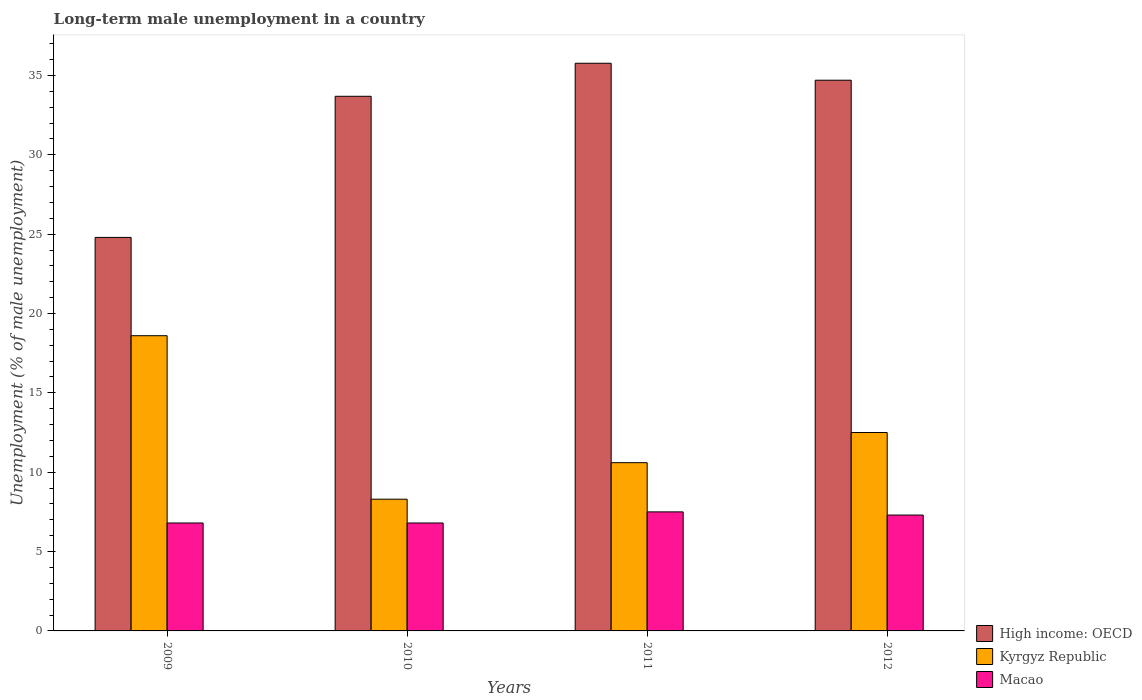Are the number of bars on each tick of the X-axis equal?
Offer a terse response. Yes. How many bars are there on the 4th tick from the left?
Give a very brief answer. 3. How many bars are there on the 3rd tick from the right?
Offer a very short reply. 3. In how many cases, is the number of bars for a given year not equal to the number of legend labels?
Offer a terse response. 0. What is the percentage of long-term unemployed male population in High income: OECD in 2012?
Your answer should be compact. 34.7. Across all years, what is the maximum percentage of long-term unemployed male population in Macao?
Your answer should be compact. 7.5. Across all years, what is the minimum percentage of long-term unemployed male population in Macao?
Provide a succinct answer. 6.8. In which year was the percentage of long-term unemployed male population in High income: OECD minimum?
Offer a terse response. 2009. What is the total percentage of long-term unemployed male population in Macao in the graph?
Make the answer very short. 28.4. What is the difference between the percentage of long-term unemployed male population in Macao in 2009 and that in 2012?
Ensure brevity in your answer.  -0.5. What is the difference between the percentage of long-term unemployed male population in High income: OECD in 2010 and the percentage of long-term unemployed male population in Kyrgyz Republic in 2012?
Provide a short and direct response. 21.19. What is the average percentage of long-term unemployed male population in Kyrgyz Republic per year?
Give a very brief answer. 12.5. In the year 2011, what is the difference between the percentage of long-term unemployed male population in Macao and percentage of long-term unemployed male population in Kyrgyz Republic?
Your response must be concise. -3.1. What is the ratio of the percentage of long-term unemployed male population in High income: OECD in 2010 to that in 2012?
Provide a succinct answer. 0.97. Is the percentage of long-term unemployed male population in Macao in 2009 less than that in 2010?
Your answer should be very brief. No. What is the difference between the highest and the second highest percentage of long-term unemployed male population in Macao?
Provide a short and direct response. 0.2. What is the difference between the highest and the lowest percentage of long-term unemployed male population in Kyrgyz Republic?
Your answer should be very brief. 10.3. In how many years, is the percentage of long-term unemployed male population in Macao greater than the average percentage of long-term unemployed male population in Macao taken over all years?
Offer a terse response. 2. What does the 2nd bar from the left in 2010 represents?
Give a very brief answer. Kyrgyz Republic. What does the 2nd bar from the right in 2009 represents?
Make the answer very short. Kyrgyz Republic. How many bars are there?
Your answer should be compact. 12. How many years are there in the graph?
Keep it short and to the point. 4. Are the values on the major ticks of Y-axis written in scientific E-notation?
Offer a very short reply. No. Does the graph contain grids?
Offer a very short reply. No. How many legend labels are there?
Offer a very short reply. 3. What is the title of the graph?
Give a very brief answer. Long-term male unemployment in a country. Does "Greece" appear as one of the legend labels in the graph?
Provide a short and direct response. No. What is the label or title of the X-axis?
Your answer should be very brief. Years. What is the label or title of the Y-axis?
Make the answer very short. Unemployment (% of male unemployment). What is the Unemployment (% of male unemployment) of High income: OECD in 2009?
Your response must be concise. 24.79. What is the Unemployment (% of male unemployment) in Kyrgyz Republic in 2009?
Ensure brevity in your answer.  18.6. What is the Unemployment (% of male unemployment) in Macao in 2009?
Offer a very short reply. 6.8. What is the Unemployment (% of male unemployment) of High income: OECD in 2010?
Your response must be concise. 33.69. What is the Unemployment (% of male unemployment) in Kyrgyz Republic in 2010?
Provide a short and direct response. 8.3. What is the Unemployment (% of male unemployment) of Macao in 2010?
Offer a very short reply. 6.8. What is the Unemployment (% of male unemployment) in High income: OECD in 2011?
Ensure brevity in your answer.  35.77. What is the Unemployment (% of male unemployment) of Kyrgyz Republic in 2011?
Ensure brevity in your answer.  10.6. What is the Unemployment (% of male unemployment) in Macao in 2011?
Your answer should be compact. 7.5. What is the Unemployment (% of male unemployment) in High income: OECD in 2012?
Keep it short and to the point. 34.7. What is the Unemployment (% of male unemployment) of Macao in 2012?
Ensure brevity in your answer.  7.3. Across all years, what is the maximum Unemployment (% of male unemployment) of High income: OECD?
Provide a succinct answer. 35.77. Across all years, what is the maximum Unemployment (% of male unemployment) of Kyrgyz Republic?
Offer a terse response. 18.6. Across all years, what is the minimum Unemployment (% of male unemployment) of High income: OECD?
Your answer should be compact. 24.79. Across all years, what is the minimum Unemployment (% of male unemployment) in Kyrgyz Republic?
Your answer should be very brief. 8.3. Across all years, what is the minimum Unemployment (% of male unemployment) of Macao?
Provide a succinct answer. 6.8. What is the total Unemployment (% of male unemployment) of High income: OECD in the graph?
Offer a very short reply. 128.94. What is the total Unemployment (% of male unemployment) of Macao in the graph?
Provide a short and direct response. 28.4. What is the difference between the Unemployment (% of male unemployment) in High income: OECD in 2009 and that in 2010?
Provide a succinct answer. -8.89. What is the difference between the Unemployment (% of male unemployment) in High income: OECD in 2009 and that in 2011?
Your response must be concise. -10.97. What is the difference between the Unemployment (% of male unemployment) in Macao in 2009 and that in 2011?
Provide a short and direct response. -0.7. What is the difference between the Unemployment (% of male unemployment) of High income: OECD in 2009 and that in 2012?
Offer a very short reply. -9.9. What is the difference between the Unemployment (% of male unemployment) in Kyrgyz Republic in 2009 and that in 2012?
Provide a short and direct response. 6.1. What is the difference between the Unemployment (% of male unemployment) in High income: OECD in 2010 and that in 2011?
Give a very brief answer. -2.08. What is the difference between the Unemployment (% of male unemployment) in Macao in 2010 and that in 2011?
Give a very brief answer. -0.7. What is the difference between the Unemployment (% of male unemployment) of High income: OECD in 2010 and that in 2012?
Offer a very short reply. -1.01. What is the difference between the Unemployment (% of male unemployment) of Kyrgyz Republic in 2010 and that in 2012?
Offer a terse response. -4.2. What is the difference between the Unemployment (% of male unemployment) of Macao in 2010 and that in 2012?
Your answer should be compact. -0.5. What is the difference between the Unemployment (% of male unemployment) of High income: OECD in 2011 and that in 2012?
Offer a very short reply. 1.07. What is the difference between the Unemployment (% of male unemployment) in Kyrgyz Republic in 2011 and that in 2012?
Provide a succinct answer. -1.9. What is the difference between the Unemployment (% of male unemployment) of High income: OECD in 2009 and the Unemployment (% of male unemployment) of Kyrgyz Republic in 2010?
Give a very brief answer. 16.49. What is the difference between the Unemployment (% of male unemployment) in High income: OECD in 2009 and the Unemployment (% of male unemployment) in Macao in 2010?
Offer a terse response. 17.99. What is the difference between the Unemployment (% of male unemployment) in Kyrgyz Republic in 2009 and the Unemployment (% of male unemployment) in Macao in 2010?
Provide a short and direct response. 11.8. What is the difference between the Unemployment (% of male unemployment) in High income: OECD in 2009 and the Unemployment (% of male unemployment) in Kyrgyz Republic in 2011?
Give a very brief answer. 14.19. What is the difference between the Unemployment (% of male unemployment) in High income: OECD in 2009 and the Unemployment (% of male unemployment) in Macao in 2011?
Make the answer very short. 17.29. What is the difference between the Unemployment (% of male unemployment) in Kyrgyz Republic in 2009 and the Unemployment (% of male unemployment) in Macao in 2011?
Provide a short and direct response. 11.1. What is the difference between the Unemployment (% of male unemployment) of High income: OECD in 2009 and the Unemployment (% of male unemployment) of Kyrgyz Republic in 2012?
Make the answer very short. 12.29. What is the difference between the Unemployment (% of male unemployment) of High income: OECD in 2009 and the Unemployment (% of male unemployment) of Macao in 2012?
Make the answer very short. 17.49. What is the difference between the Unemployment (% of male unemployment) of Kyrgyz Republic in 2009 and the Unemployment (% of male unemployment) of Macao in 2012?
Offer a very short reply. 11.3. What is the difference between the Unemployment (% of male unemployment) in High income: OECD in 2010 and the Unemployment (% of male unemployment) in Kyrgyz Republic in 2011?
Your answer should be very brief. 23.09. What is the difference between the Unemployment (% of male unemployment) in High income: OECD in 2010 and the Unemployment (% of male unemployment) in Macao in 2011?
Your answer should be very brief. 26.19. What is the difference between the Unemployment (% of male unemployment) of Kyrgyz Republic in 2010 and the Unemployment (% of male unemployment) of Macao in 2011?
Provide a short and direct response. 0.8. What is the difference between the Unemployment (% of male unemployment) of High income: OECD in 2010 and the Unemployment (% of male unemployment) of Kyrgyz Republic in 2012?
Provide a short and direct response. 21.19. What is the difference between the Unemployment (% of male unemployment) in High income: OECD in 2010 and the Unemployment (% of male unemployment) in Macao in 2012?
Keep it short and to the point. 26.39. What is the difference between the Unemployment (% of male unemployment) in High income: OECD in 2011 and the Unemployment (% of male unemployment) in Kyrgyz Republic in 2012?
Keep it short and to the point. 23.27. What is the difference between the Unemployment (% of male unemployment) in High income: OECD in 2011 and the Unemployment (% of male unemployment) in Macao in 2012?
Make the answer very short. 28.47. What is the average Unemployment (% of male unemployment) in High income: OECD per year?
Make the answer very short. 32.24. What is the average Unemployment (% of male unemployment) in Kyrgyz Republic per year?
Provide a succinct answer. 12.5. In the year 2009, what is the difference between the Unemployment (% of male unemployment) in High income: OECD and Unemployment (% of male unemployment) in Kyrgyz Republic?
Keep it short and to the point. 6.19. In the year 2009, what is the difference between the Unemployment (% of male unemployment) in High income: OECD and Unemployment (% of male unemployment) in Macao?
Offer a terse response. 17.99. In the year 2010, what is the difference between the Unemployment (% of male unemployment) in High income: OECD and Unemployment (% of male unemployment) in Kyrgyz Republic?
Provide a succinct answer. 25.39. In the year 2010, what is the difference between the Unemployment (% of male unemployment) of High income: OECD and Unemployment (% of male unemployment) of Macao?
Offer a terse response. 26.89. In the year 2011, what is the difference between the Unemployment (% of male unemployment) of High income: OECD and Unemployment (% of male unemployment) of Kyrgyz Republic?
Keep it short and to the point. 25.17. In the year 2011, what is the difference between the Unemployment (% of male unemployment) of High income: OECD and Unemployment (% of male unemployment) of Macao?
Ensure brevity in your answer.  28.27. In the year 2011, what is the difference between the Unemployment (% of male unemployment) of Kyrgyz Republic and Unemployment (% of male unemployment) of Macao?
Offer a very short reply. 3.1. In the year 2012, what is the difference between the Unemployment (% of male unemployment) in High income: OECD and Unemployment (% of male unemployment) in Kyrgyz Republic?
Ensure brevity in your answer.  22.2. In the year 2012, what is the difference between the Unemployment (% of male unemployment) of High income: OECD and Unemployment (% of male unemployment) of Macao?
Offer a terse response. 27.4. What is the ratio of the Unemployment (% of male unemployment) in High income: OECD in 2009 to that in 2010?
Give a very brief answer. 0.74. What is the ratio of the Unemployment (% of male unemployment) of Kyrgyz Republic in 2009 to that in 2010?
Your answer should be compact. 2.24. What is the ratio of the Unemployment (% of male unemployment) in High income: OECD in 2009 to that in 2011?
Ensure brevity in your answer.  0.69. What is the ratio of the Unemployment (% of male unemployment) in Kyrgyz Republic in 2009 to that in 2011?
Provide a succinct answer. 1.75. What is the ratio of the Unemployment (% of male unemployment) of Macao in 2009 to that in 2011?
Make the answer very short. 0.91. What is the ratio of the Unemployment (% of male unemployment) in High income: OECD in 2009 to that in 2012?
Your answer should be compact. 0.71. What is the ratio of the Unemployment (% of male unemployment) of Kyrgyz Republic in 2009 to that in 2012?
Keep it short and to the point. 1.49. What is the ratio of the Unemployment (% of male unemployment) in Macao in 2009 to that in 2012?
Your response must be concise. 0.93. What is the ratio of the Unemployment (% of male unemployment) of High income: OECD in 2010 to that in 2011?
Keep it short and to the point. 0.94. What is the ratio of the Unemployment (% of male unemployment) in Kyrgyz Republic in 2010 to that in 2011?
Your response must be concise. 0.78. What is the ratio of the Unemployment (% of male unemployment) in Macao in 2010 to that in 2011?
Ensure brevity in your answer.  0.91. What is the ratio of the Unemployment (% of male unemployment) of High income: OECD in 2010 to that in 2012?
Your answer should be very brief. 0.97. What is the ratio of the Unemployment (% of male unemployment) of Kyrgyz Republic in 2010 to that in 2012?
Ensure brevity in your answer.  0.66. What is the ratio of the Unemployment (% of male unemployment) in Macao in 2010 to that in 2012?
Ensure brevity in your answer.  0.93. What is the ratio of the Unemployment (% of male unemployment) of High income: OECD in 2011 to that in 2012?
Ensure brevity in your answer.  1.03. What is the ratio of the Unemployment (% of male unemployment) in Kyrgyz Republic in 2011 to that in 2012?
Ensure brevity in your answer.  0.85. What is the ratio of the Unemployment (% of male unemployment) of Macao in 2011 to that in 2012?
Keep it short and to the point. 1.03. What is the difference between the highest and the second highest Unemployment (% of male unemployment) in High income: OECD?
Your answer should be very brief. 1.07. What is the difference between the highest and the second highest Unemployment (% of male unemployment) of Macao?
Your answer should be compact. 0.2. What is the difference between the highest and the lowest Unemployment (% of male unemployment) in High income: OECD?
Offer a terse response. 10.97. 